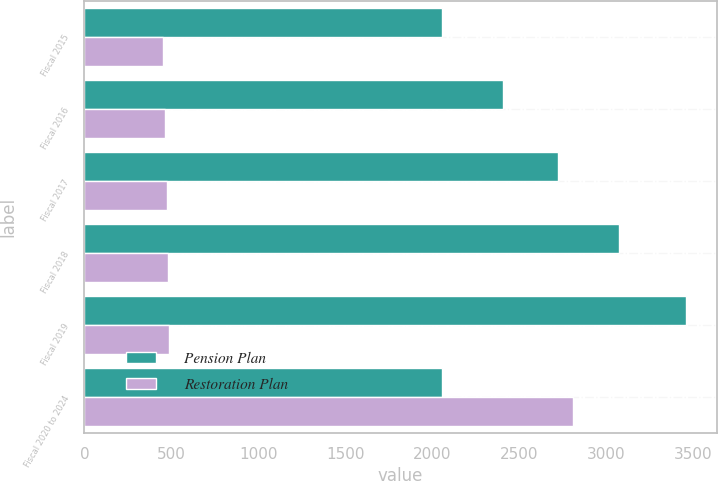Convert chart. <chart><loc_0><loc_0><loc_500><loc_500><stacked_bar_chart><ecel><fcel>Fiscal 2015<fcel>Fiscal 2016<fcel>Fiscal 2017<fcel>Fiscal 2018<fcel>Fiscal 2019<fcel>Fiscal 2020 to 2024<nl><fcel>Pension Plan<fcel>2056<fcel>2407<fcel>2726<fcel>3076<fcel>3464<fcel>2056<nl><fcel>Restoration Plan<fcel>451<fcel>466<fcel>476<fcel>482<fcel>485<fcel>2810<nl></chart> 